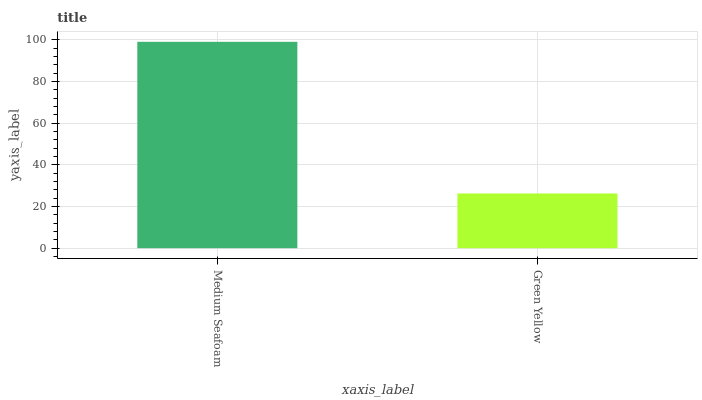Is Green Yellow the minimum?
Answer yes or no. Yes. Is Medium Seafoam the maximum?
Answer yes or no. Yes. Is Green Yellow the maximum?
Answer yes or no. No. Is Medium Seafoam greater than Green Yellow?
Answer yes or no. Yes. Is Green Yellow less than Medium Seafoam?
Answer yes or no. Yes. Is Green Yellow greater than Medium Seafoam?
Answer yes or no. No. Is Medium Seafoam less than Green Yellow?
Answer yes or no. No. Is Medium Seafoam the high median?
Answer yes or no. Yes. Is Green Yellow the low median?
Answer yes or no. Yes. Is Green Yellow the high median?
Answer yes or no. No. Is Medium Seafoam the low median?
Answer yes or no. No. 